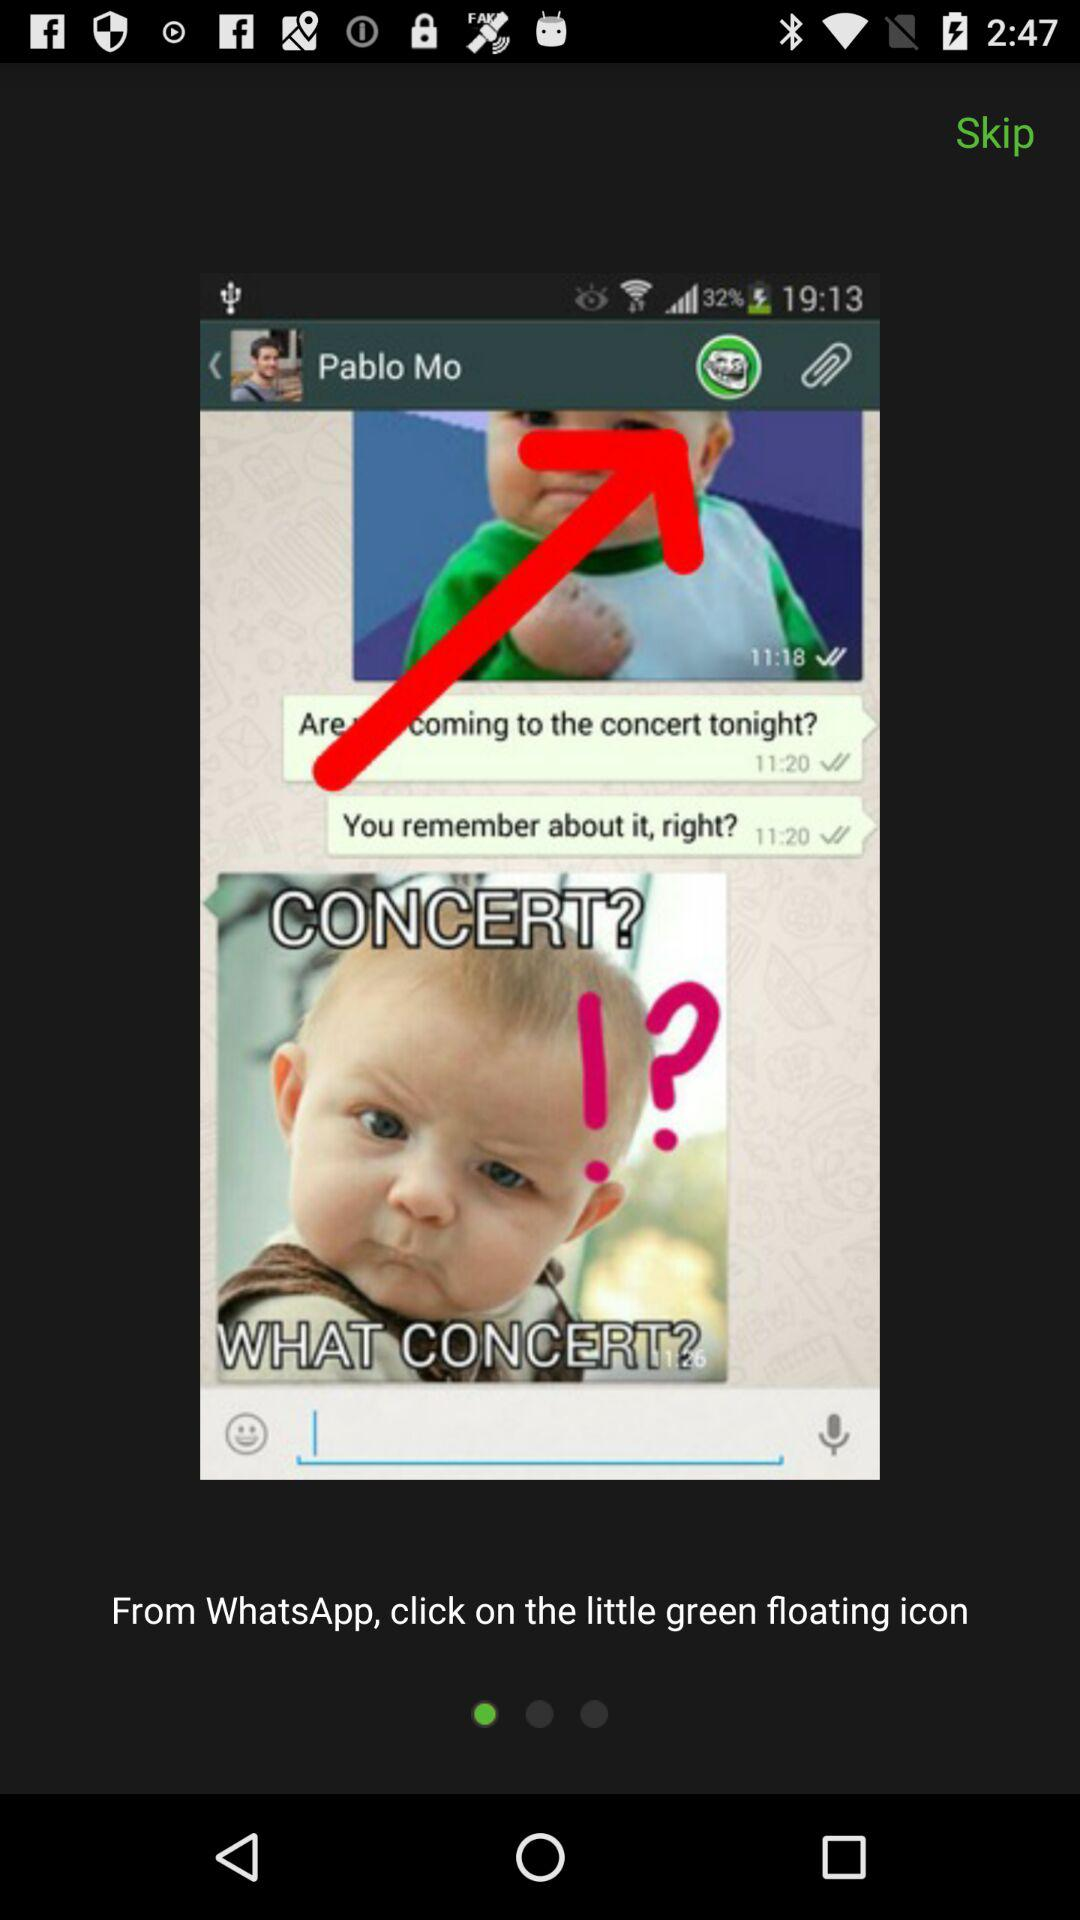What is the name of the Whatsapp profile user? The name of the user is "Pablo Mo". 